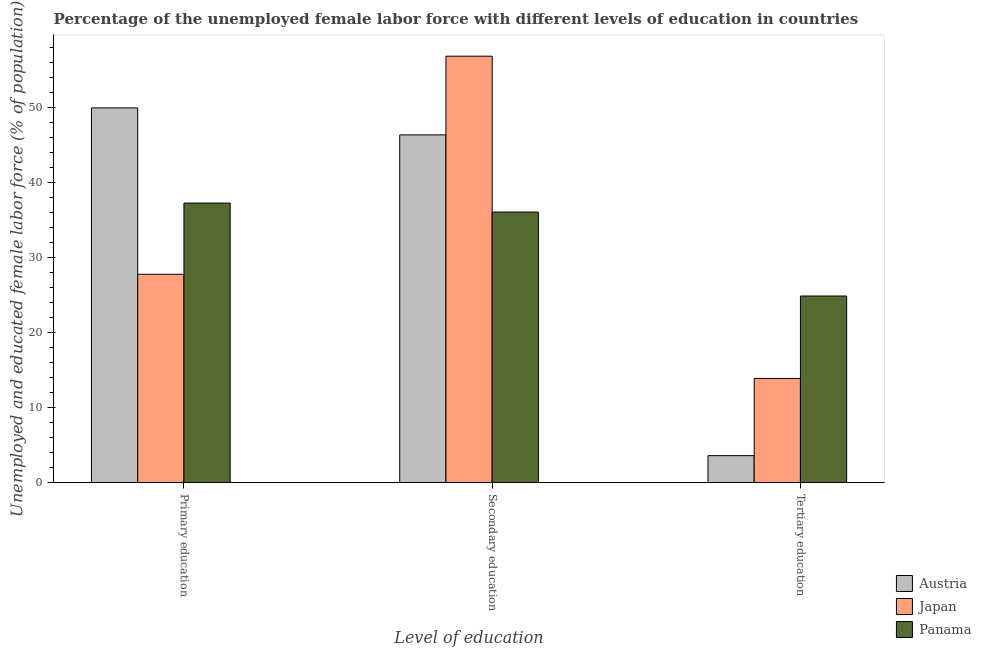How many groups of bars are there?
Ensure brevity in your answer.  3. Are the number of bars per tick equal to the number of legend labels?
Offer a very short reply. Yes. How many bars are there on the 1st tick from the left?
Provide a short and direct response. 3. What is the label of the 1st group of bars from the left?
Your answer should be very brief. Primary education. What is the percentage of female labor force who received secondary education in Japan?
Provide a short and direct response. 56.9. Across all countries, what is the maximum percentage of female labor force who received tertiary education?
Your response must be concise. 24.9. Across all countries, what is the minimum percentage of female labor force who received tertiary education?
Make the answer very short. 3.6. In which country was the percentage of female labor force who received secondary education minimum?
Ensure brevity in your answer.  Panama. What is the total percentage of female labor force who received tertiary education in the graph?
Make the answer very short. 42.4. What is the difference between the percentage of female labor force who received tertiary education in Japan and that in Panama?
Ensure brevity in your answer.  -11. What is the difference between the percentage of female labor force who received tertiary education in Panama and the percentage of female labor force who received primary education in Austria?
Give a very brief answer. -25.1. What is the average percentage of female labor force who received secondary education per country?
Your answer should be compact. 46.47. What is the difference between the percentage of female labor force who received secondary education and percentage of female labor force who received tertiary education in Austria?
Give a very brief answer. 42.8. In how many countries, is the percentage of female labor force who received secondary education greater than 42 %?
Provide a short and direct response. 2. What is the ratio of the percentage of female labor force who received tertiary education in Austria to that in Panama?
Offer a very short reply. 0.14. Is the percentage of female labor force who received tertiary education in Japan less than that in Austria?
Offer a terse response. No. What is the difference between the highest and the second highest percentage of female labor force who received primary education?
Provide a succinct answer. 12.7. What is the difference between the highest and the lowest percentage of female labor force who received secondary education?
Offer a very short reply. 20.8. In how many countries, is the percentage of female labor force who received tertiary education greater than the average percentage of female labor force who received tertiary education taken over all countries?
Your response must be concise. 1. What does the 2nd bar from the left in Tertiary education represents?
Offer a very short reply. Japan. What does the 1st bar from the right in Secondary education represents?
Make the answer very short. Panama. Are all the bars in the graph horizontal?
Your answer should be compact. No. What is the difference between two consecutive major ticks on the Y-axis?
Keep it short and to the point. 10. Does the graph contain grids?
Your response must be concise. No. How many legend labels are there?
Provide a short and direct response. 3. What is the title of the graph?
Your response must be concise. Percentage of the unemployed female labor force with different levels of education in countries. Does "Sudan" appear as one of the legend labels in the graph?
Provide a succinct answer. No. What is the label or title of the X-axis?
Your answer should be very brief. Level of education. What is the label or title of the Y-axis?
Your answer should be compact. Unemployed and educated female labor force (% of population). What is the Unemployed and educated female labor force (% of population) of Japan in Primary education?
Your response must be concise. 27.8. What is the Unemployed and educated female labor force (% of population) of Panama in Primary education?
Your answer should be compact. 37.3. What is the Unemployed and educated female labor force (% of population) in Austria in Secondary education?
Provide a succinct answer. 46.4. What is the Unemployed and educated female labor force (% of population) of Japan in Secondary education?
Give a very brief answer. 56.9. What is the Unemployed and educated female labor force (% of population) in Panama in Secondary education?
Provide a short and direct response. 36.1. What is the Unemployed and educated female labor force (% of population) in Austria in Tertiary education?
Keep it short and to the point. 3.6. What is the Unemployed and educated female labor force (% of population) of Japan in Tertiary education?
Offer a terse response. 13.9. What is the Unemployed and educated female labor force (% of population) in Panama in Tertiary education?
Provide a short and direct response. 24.9. Across all Level of education, what is the maximum Unemployed and educated female labor force (% of population) in Austria?
Offer a terse response. 50. Across all Level of education, what is the maximum Unemployed and educated female labor force (% of population) in Japan?
Make the answer very short. 56.9. Across all Level of education, what is the maximum Unemployed and educated female labor force (% of population) in Panama?
Your response must be concise. 37.3. Across all Level of education, what is the minimum Unemployed and educated female labor force (% of population) of Austria?
Your answer should be compact. 3.6. Across all Level of education, what is the minimum Unemployed and educated female labor force (% of population) in Japan?
Your answer should be compact. 13.9. Across all Level of education, what is the minimum Unemployed and educated female labor force (% of population) of Panama?
Give a very brief answer. 24.9. What is the total Unemployed and educated female labor force (% of population) in Japan in the graph?
Your answer should be very brief. 98.6. What is the total Unemployed and educated female labor force (% of population) in Panama in the graph?
Provide a succinct answer. 98.3. What is the difference between the Unemployed and educated female labor force (% of population) of Japan in Primary education and that in Secondary education?
Keep it short and to the point. -29.1. What is the difference between the Unemployed and educated female labor force (% of population) in Austria in Primary education and that in Tertiary education?
Make the answer very short. 46.4. What is the difference between the Unemployed and educated female labor force (% of population) in Japan in Primary education and that in Tertiary education?
Ensure brevity in your answer.  13.9. What is the difference between the Unemployed and educated female labor force (% of population) of Austria in Secondary education and that in Tertiary education?
Make the answer very short. 42.8. What is the difference between the Unemployed and educated female labor force (% of population) of Japan in Primary education and the Unemployed and educated female labor force (% of population) of Panama in Secondary education?
Your answer should be very brief. -8.3. What is the difference between the Unemployed and educated female labor force (% of population) of Austria in Primary education and the Unemployed and educated female labor force (% of population) of Japan in Tertiary education?
Your answer should be very brief. 36.1. What is the difference between the Unemployed and educated female labor force (% of population) of Austria in Primary education and the Unemployed and educated female labor force (% of population) of Panama in Tertiary education?
Give a very brief answer. 25.1. What is the difference between the Unemployed and educated female labor force (% of population) of Japan in Primary education and the Unemployed and educated female labor force (% of population) of Panama in Tertiary education?
Make the answer very short. 2.9. What is the difference between the Unemployed and educated female labor force (% of population) of Austria in Secondary education and the Unemployed and educated female labor force (% of population) of Japan in Tertiary education?
Your response must be concise. 32.5. What is the difference between the Unemployed and educated female labor force (% of population) of Austria in Secondary education and the Unemployed and educated female labor force (% of population) of Panama in Tertiary education?
Provide a short and direct response. 21.5. What is the difference between the Unemployed and educated female labor force (% of population) in Japan in Secondary education and the Unemployed and educated female labor force (% of population) in Panama in Tertiary education?
Offer a very short reply. 32. What is the average Unemployed and educated female labor force (% of population) of Austria per Level of education?
Provide a succinct answer. 33.33. What is the average Unemployed and educated female labor force (% of population) of Japan per Level of education?
Offer a terse response. 32.87. What is the average Unemployed and educated female labor force (% of population) of Panama per Level of education?
Your answer should be very brief. 32.77. What is the difference between the Unemployed and educated female labor force (% of population) of Austria and Unemployed and educated female labor force (% of population) of Japan in Primary education?
Keep it short and to the point. 22.2. What is the difference between the Unemployed and educated female labor force (% of population) of Austria and Unemployed and educated female labor force (% of population) of Panama in Primary education?
Your response must be concise. 12.7. What is the difference between the Unemployed and educated female labor force (% of population) in Austria and Unemployed and educated female labor force (% of population) in Panama in Secondary education?
Give a very brief answer. 10.3. What is the difference between the Unemployed and educated female labor force (% of population) of Japan and Unemployed and educated female labor force (% of population) of Panama in Secondary education?
Give a very brief answer. 20.8. What is the difference between the Unemployed and educated female labor force (% of population) of Austria and Unemployed and educated female labor force (% of population) of Panama in Tertiary education?
Provide a succinct answer. -21.3. What is the difference between the Unemployed and educated female labor force (% of population) in Japan and Unemployed and educated female labor force (% of population) in Panama in Tertiary education?
Ensure brevity in your answer.  -11. What is the ratio of the Unemployed and educated female labor force (% of population) in Austria in Primary education to that in Secondary education?
Give a very brief answer. 1.08. What is the ratio of the Unemployed and educated female labor force (% of population) of Japan in Primary education to that in Secondary education?
Your answer should be very brief. 0.49. What is the ratio of the Unemployed and educated female labor force (% of population) in Panama in Primary education to that in Secondary education?
Make the answer very short. 1.03. What is the ratio of the Unemployed and educated female labor force (% of population) in Austria in Primary education to that in Tertiary education?
Give a very brief answer. 13.89. What is the ratio of the Unemployed and educated female labor force (% of population) in Japan in Primary education to that in Tertiary education?
Provide a succinct answer. 2. What is the ratio of the Unemployed and educated female labor force (% of population) of Panama in Primary education to that in Tertiary education?
Give a very brief answer. 1.5. What is the ratio of the Unemployed and educated female labor force (% of population) of Austria in Secondary education to that in Tertiary education?
Offer a terse response. 12.89. What is the ratio of the Unemployed and educated female labor force (% of population) of Japan in Secondary education to that in Tertiary education?
Your answer should be compact. 4.09. What is the ratio of the Unemployed and educated female labor force (% of population) of Panama in Secondary education to that in Tertiary education?
Offer a very short reply. 1.45. What is the difference between the highest and the second highest Unemployed and educated female labor force (% of population) in Japan?
Offer a very short reply. 29.1. What is the difference between the highest and the lowest Unemployed and educated female labor force (% of population) in Austria?
Give a very brief answer. 46.4. What is the difference between the highest and the lowest Unemployed and educated female labor force (% of population) in Panama?
Keep it short and to the point. 12.4. 